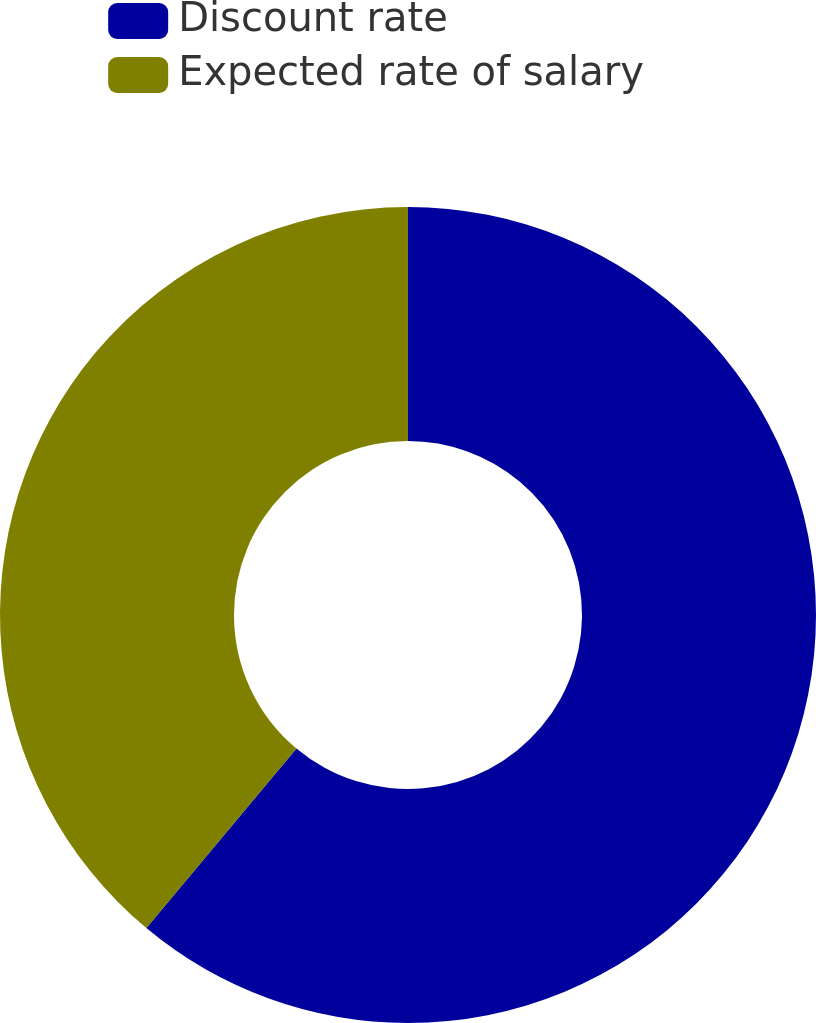Convert chart. <chart><loc_0><loc_0><loc_500><loc_500><pie_chart><fcel>Discount rate<fcel>Expected rate of salary<nl><fcel>61.08%<fcel>38.92%<nl></chart> 